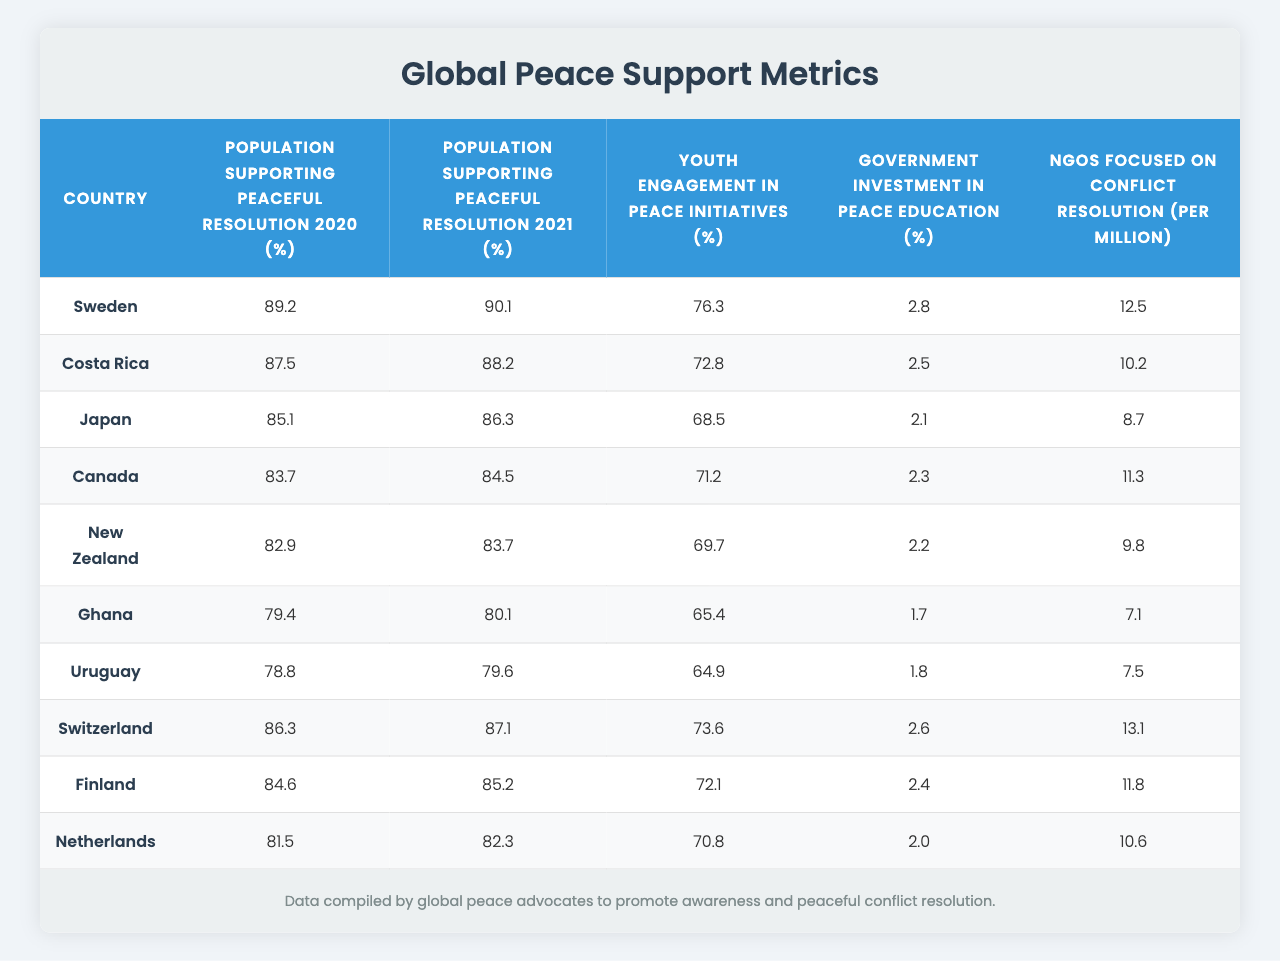What country had the highest percentage of the population supporting peaceful resolution in 2021? Looking at the "Population Supporting Peaceful Resolution 2021" column, the highest value is 90.1, which corresponds to Sweden.
Answer: Sweden What was the percentage of the population in Canada supporting peaceful resolution in 2020? The table shows that Canada's percentage for "Population Supporting Peaceful Resolution 2020" is 83.7.
Answer: 83.7 Which country had the lowest government investment in peace education? By examining the "Government Investment in Peace Education" column, Ghana has the lowest value at 1.7%.
Answer: Ghana What is the average percentage of youth engagement in peace initiatives across these countries? To find the average, sum the values for youth engagement: 76.3 + 72.8 + 68.5 + 71.2 + 69.7 + 65.4 + 64.9 + 73.6 + 72.1 + 70.8 =  695.3; then divide by 10 to get an average of 69.53.
Answer: 69.53 Is the percentage of the population supporting peaceful resolution in Switzerland higher or lower than in Finland for 2020? For 2020, Switzerland has 86.3% and Finland has 84.6%. Since 86.3 is greater than 84.6, it is higher in Switzerland.
Answer: Higher in Switzerland What was the change in the percentage of the population supporting peaceful resolution from 2020 to 2021 for New Zealand? For New Zealand, it was 82.9% in 2020 and 83.7% in 2021. The change is calculated as 83.7 - 82.9 = 0.8, indicating an increase.
Answer: 0.8% increase Which country has the most NGOs focused on conflict resolution per million people? The column "NGOs Focused on Conflict Resolution (per Million)" shows that Switzerland has the highest number with 13.1 NGOs per million.
Answer: Switzerland What is the difference in percentage points between the highest and lowest support for peaceful resolution in 2021 among these countries? The highest support percentage in 2021 is 90.1% (Sweden) and the lowest is 79.6% (Uruguay). The difference is 90.1 - 79.6 = 10.5 percentage points.
Answer: 10.5 percentage points Is youth engagement in peace initiatives generally higher or lower than government investment in peace education across these countries? Youth engagement percentages average around 70% while government investment rates are significantly lower, with the highest being 2.8%. Thus, youth engagement is generally higher than government investment.
Answer: Higher What percentage of the population in Japan supported peaceful resolution in 2020? The table indicates that Japan had a 85.1% support for peaceful resolution in 2020.
Answer: 85.1% How does the supporting percentage for peaceful resolution in Costa Rica compare to that of Ghana in 2021? For 2021, Costa Rica has 88.2% and Ghana has 80.1%. Since 88.2% is greater than 80.1%, Costa Rica has a higher percentage.
Answer: Higher in Costa Rica 